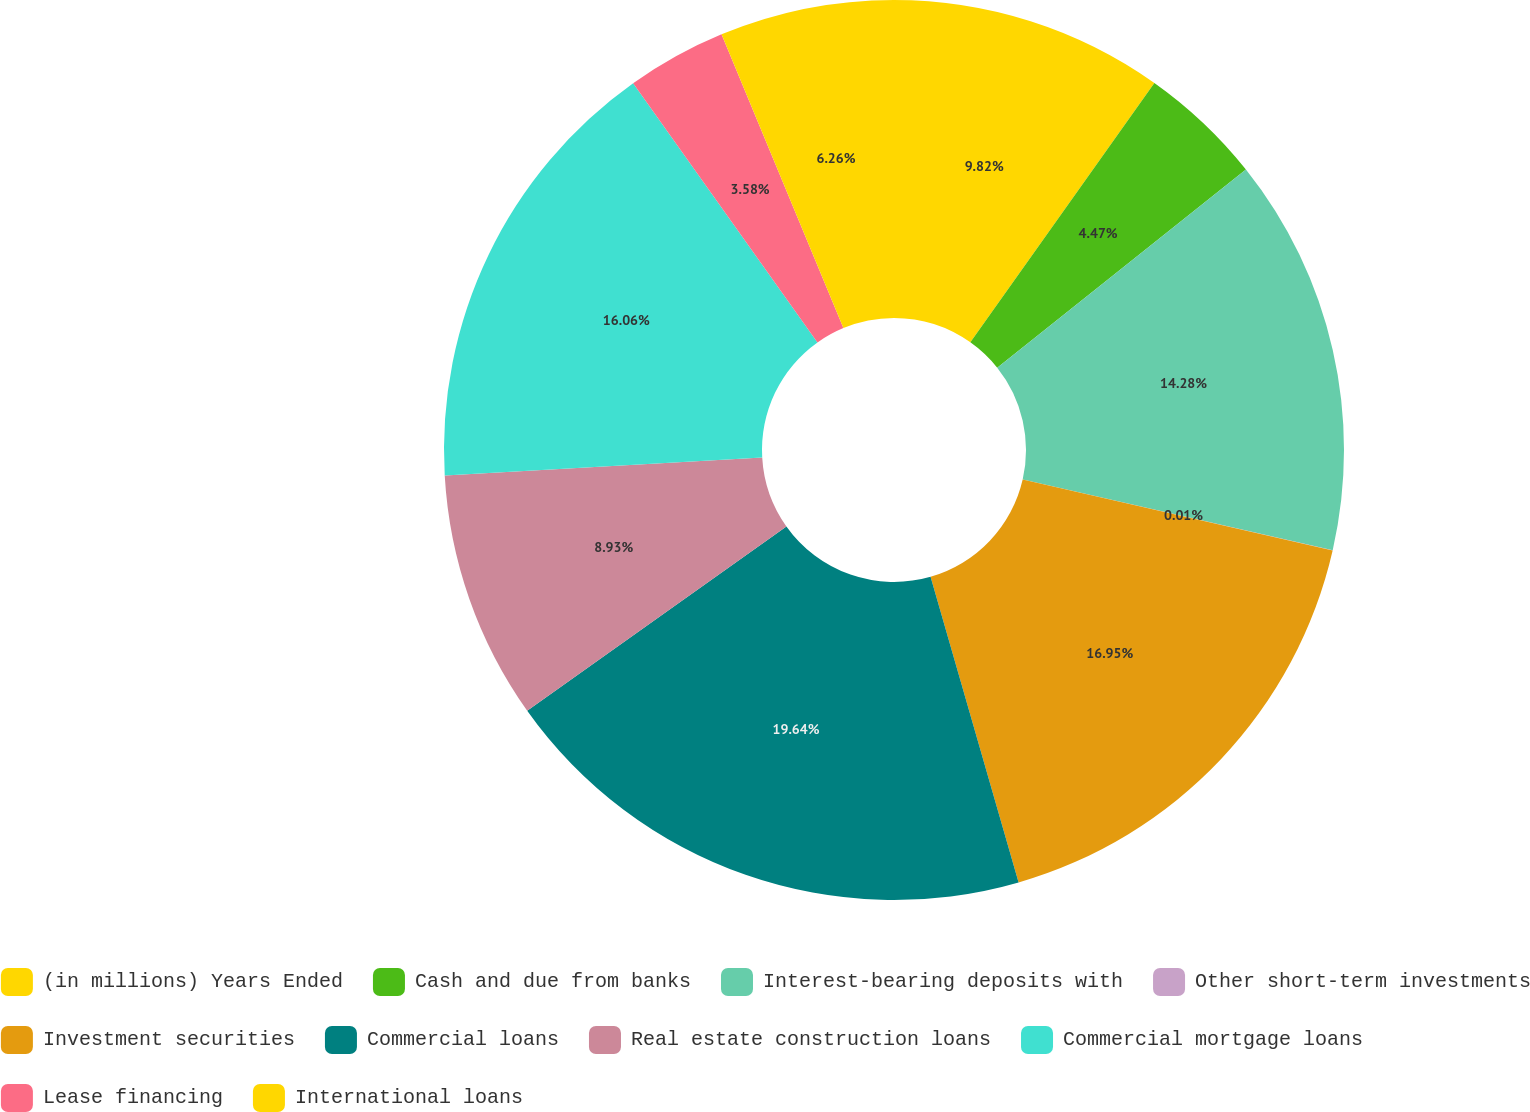Convert chart to OTSL. <chart><loc_0><loc_0><loc_500><loc_500><pie_chart><fcel>(in millions) Years Ended<fcel>Cash and due from banks<fcel>Interest-bearing deposits with<fcel>Other short-term investments<fcel>Investment securities<fcel>Commercial loans<fcel>Real estate construction loans<fcel>Commercial mortgage loans<fcel>Lease financing<fcel>International loans<nl><fcel>9.82%<fcel>4.47%<fcel>14.28%<fcel>0.01%<fcel>16.95%<fcel>19.63%<fcel>8.93%<fcel>16.06%<fcel>3.58%<fcel>6.26%<nl></chart> 